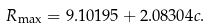Convert formula to latex. <formula><loc_0><loc_0><loc_500><loc_500>R _ { \max } = 9 . 1 0 1 9 5 + 2 . 0 8 3 0 4 c .</formula> 